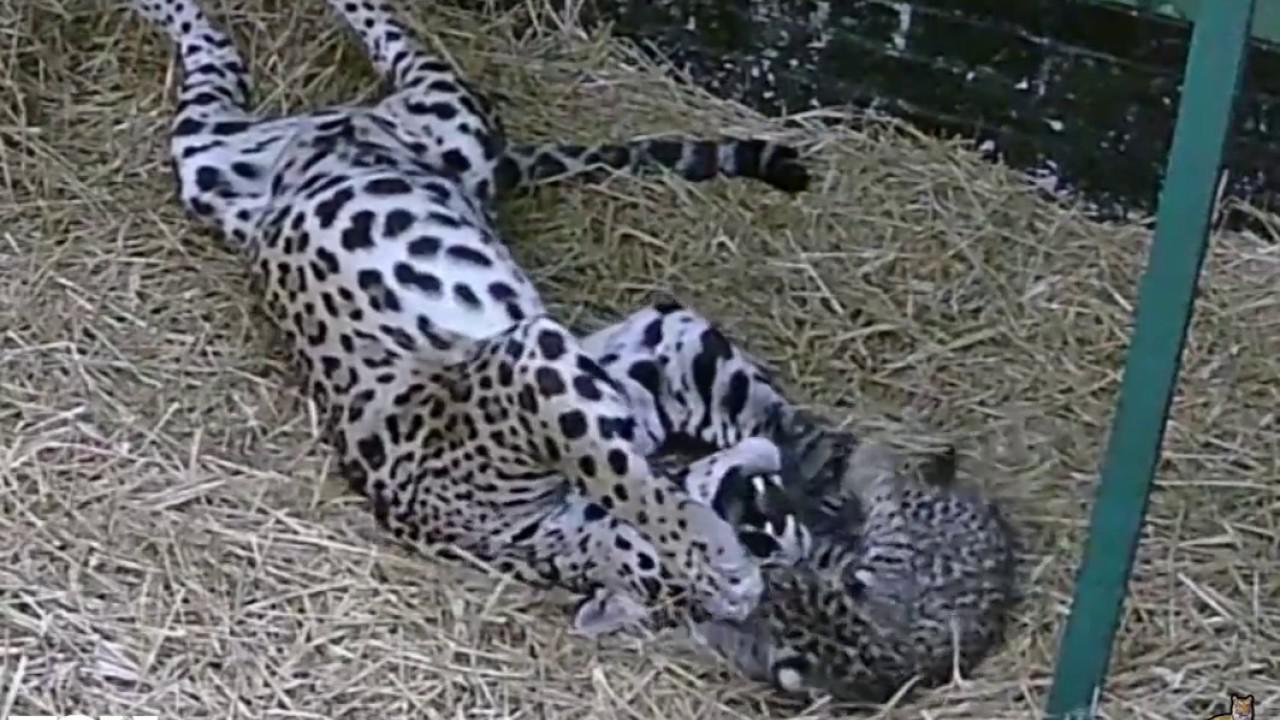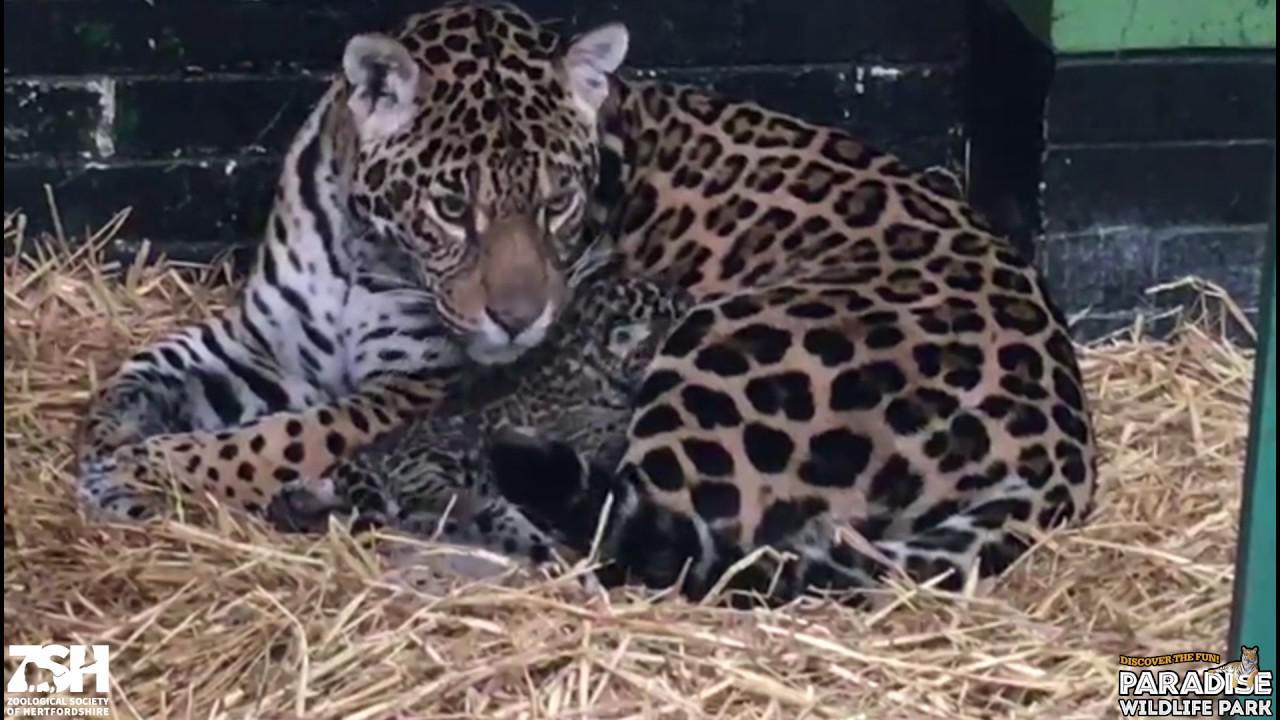The first image is the image on the left, the second image is the image on the right. Examine the images to the left and right. Is the description "Both images have straw bedding." accurate? Answer yes or no. Yes. 